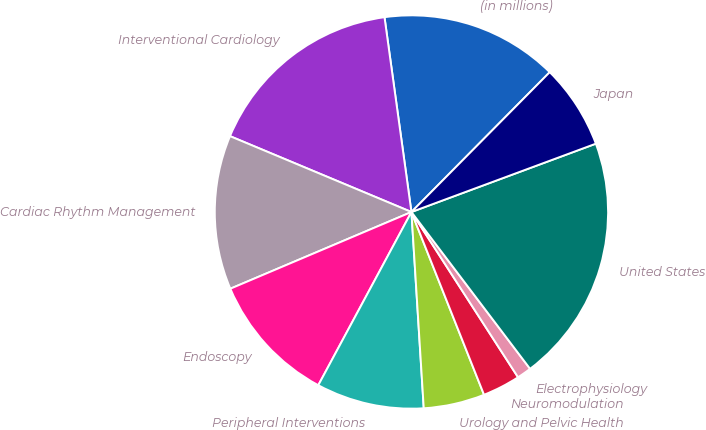<chart> <loc_0><loc_0><loc_500><loc_500><pie_chart><fcel>(in millions)<fcel>Interventional Cardiology<fcel>Cardiac Rhythm Management<fcel>Endoscopy<fcel>Peripheral Interventions<fcel>Urology and Pelvic Health<fcel>Neuromodulation<fcel>Electrophysiology<fcel>United States<fcel>Japan<nl><fcel>14.6%<fcel>16.51%<fcel>12.68%<fcel>10.77%<fcel>8.85%<fcel>5.02%<fcel>3.1%<fcel>1.19%<fcel>20.34%<fcel>6.94%<nl></chart> 